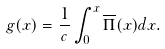<formula> <loc_0><loc_0><loc_500><loc_500>g ( x ) = \frac { 1 } { c } \int _ { 0 } ^ { x } \overline { \Pi } ( x ) d x .</formula> 